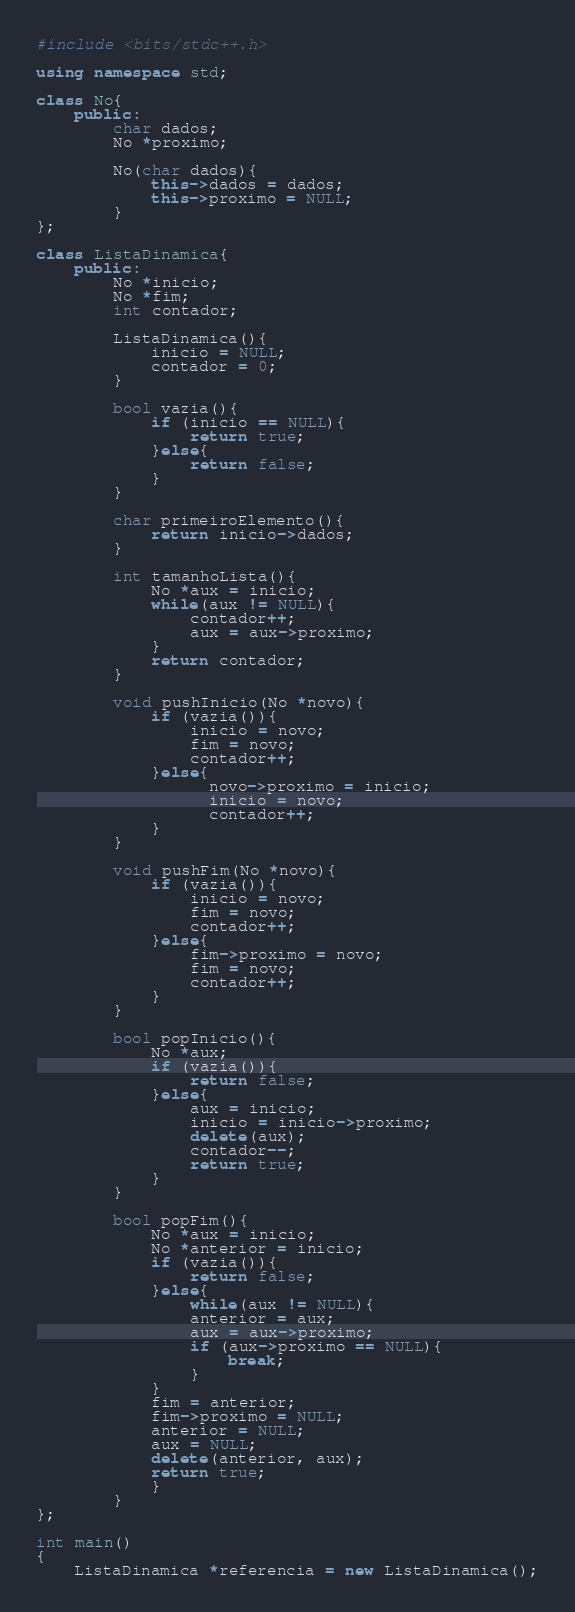<code> <loc_0><loc_0><loc_500><loc_500><_C++_>#include <bits/stdc++.h>
 
using namespace std;
 
class No{
    public:
        char dados;
        No *proximo;

        No(char dados){
            this->dados = dados;
            this->proximo = NULL;
        }
};
 
class ListaDinamica{
    public:
        No *inicio;
        No *fim;
        int contador;
 
        ListaDinamica(){
            inicio = NULL;
            contador = 0;
        }
 
        bool vazia(){
            if (inicio == NULL){
                return true;
            }else{
                return false;
            }
        }
 
        char primeiroElemento(){
            return inicio->dados;
        }
 
        int tamanhoLista(){
            No *aux = inicio;
            while(aux != NULL){
                contador++;
                aux = aux->proximo;
            }
            return contador;
        }
 
        void pushInicio(No *novo){
            if (vazia()){
                inicio = novo;
                fim = novo;
                contador++;
            }else{
                  novo->proximo = inicio;
                  inicio = novo;
                  contador++;
            }
        }
 
        void pushFim(No *novo){
            if (vazia()){
                inicio = novo;
                fim = novo;
                contador++;
            }else{  
                fim->proximo = novo;
                fim = novo;
                contador++;
            }
        }
 
        bool popInicio(){
            No *aux;
            if (vazia()){
                return false;
            }else{
                aux = inicio;
                inicio = inicio->proximo;
                delete(aux);
                contador--;
                return true;
            }
        }
     
        bool popFim(){
            No *aux = inicio;
            No *anterior = inicio;
            if (vazia()){
                return false;
            }else{
                while(aux != NULL){
                anterior = aux;
                aux = aux->proximo;
                if (aux->proximo == NULL){
                    break;
                }
            }
            fim = anterior;
            fim->proximo = NULL;
            anterior = NULL;
            aux = NULL;
            delete(anterior, aux); 
            return true; 
            }
        }
};
 
int main()
{
    ListaDinamica *referencia = new ListaDinamica();</code> 